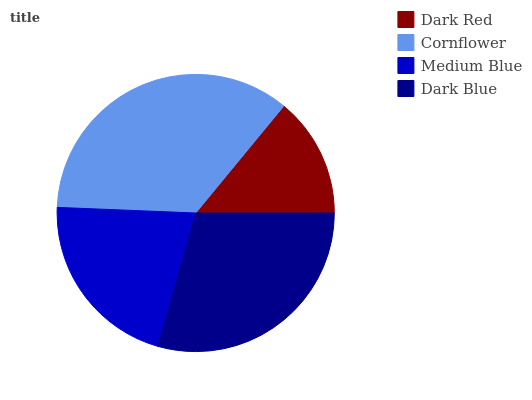Is Dark Red the minimum?
Answer yes or no. Yes. Is Cornflower the maximum?
Answer yes or no. Yes. Is Medium Blue the minimum?
Answer yes or no. No. Is Medium Blue the maximum?
Answer yes or no. No. Is Cornflower greater than Medium Blue?
Answer yes or no. Yes. Is Medium Blue less than Cornflower?
Answer yes or no. Yes. Is Medium Blue greater than Cornflower?
Answer yes or no. No. Is Cornflower less than Medium Blue?
Answer yes or no. No. Is Dark Blue the high median?
Answer yes or no. Yes. Is Medium Blue the low median?
Answer yes or no. Yes. Is Dark Red the high median?
Answer yes or no. No. Is Cornflower the low median?
Answer yes or no. No. 